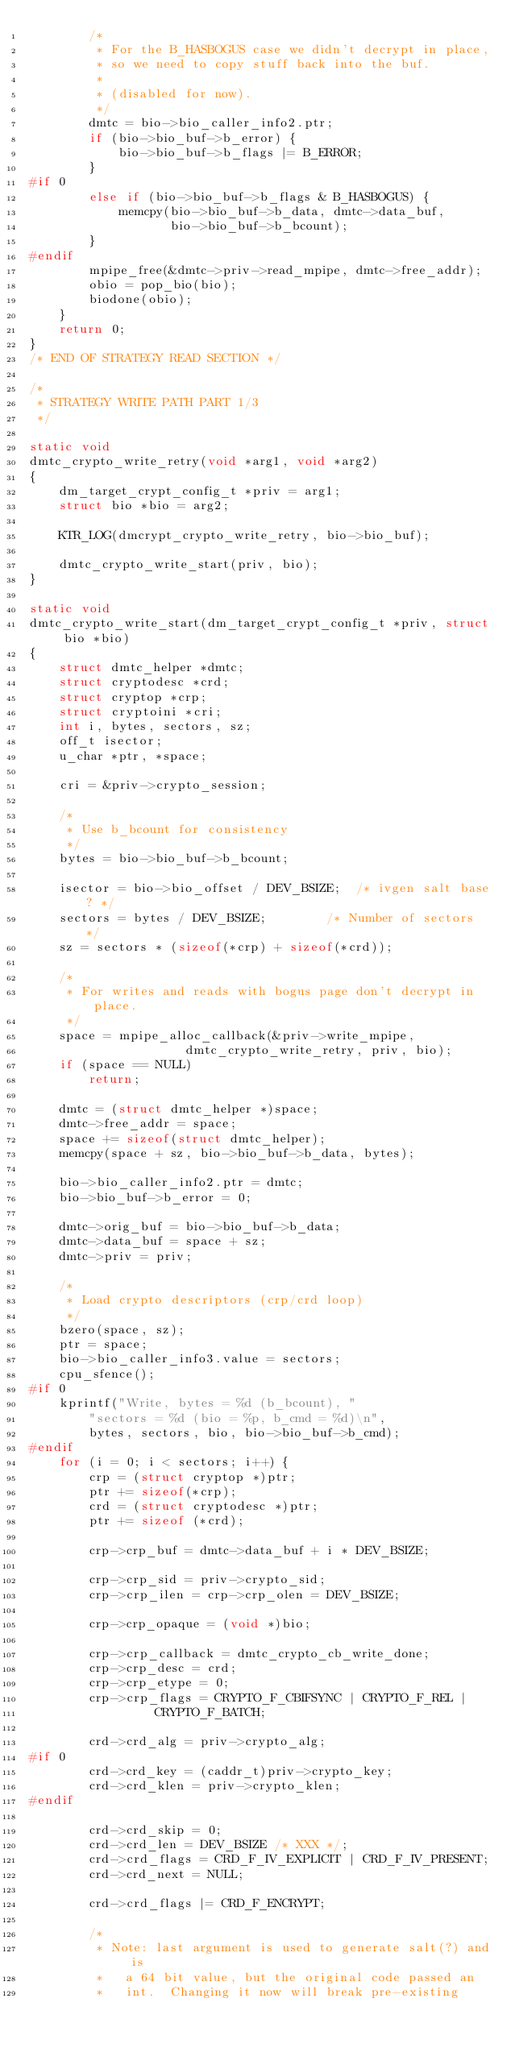<code> <loc_0><loc_0><loc_500><loc_500><_C_>		/*
		 * For the B_HASBOGUS case we didn't decrypt in place,
		 * so we need to copy stuff back into the buf.
		 *
		 * (disabled for now).
		 */
		dmtc = bio->bio_caller_info2.ptr;
		if (bio->bio_buf->b_error) {
			bio->bio_buf->b_flags |= B_ERROR;
		}
#if 0
		else if (bio->bio_buf->b_flags & B_HASBOGUS) {
			memcpy(bio->bio_buf->b_data, dmtc->data_buf,
			       bio->bio_buf->b_bcount);
		}
#endif
		mpipe_free(&dmtc->priv->read_mpipe, dmtc->free_addr);
		obio = pop_bio(bio);
		biodone(obio);
	}
	return 0;
}
/* END OF STRATEGY READ SECTION */

/*
 * STRATEGY WRITE PATH PART 1/3
 */

static void
dmtc_crypto_write_retry(void *arg1, void *arg2)
{
	dm_target_crypt_config_t *priv = arg1;
	struct bio *bio = arg2;

	KTR_LOG(dmcrypt_crypto_write_retry, bio->bio_buf);

	dmtc_crypto_write_start(priv, bio);
}

static void
dmtc_crypto_write_start(dm_target_crypt_config_t *priv, struct bio *bio)
{
	struct dmtc_helper *dmtc;
	struct cryptodesc *crd;
	struct cryptop *crp;
	struct cryptoini *cri;
	int i, bytes, sectors, sz;
	off_t isector;
	u_char *ptr, *space;

	cri = &priv->crypto_session;

	/*
	 * Use b_bcount for consistency
	 */
	bytes = bio->bio_buf->b_bcount;

	isector = bio->bio_offset / DEV_BSIZE;	/* ivgen salt base? */
	sectors = bytes / DEV_BSIZE;		/* Number of sectors */
	sz = sectors * (sizeof(*crp) + sizeof(*crd));

	/*
	 * For writes and reads with bogus page don't decrypt in place.
	 */
	space = mpipe_alloc_callback(&priv->write_mpipe,
				     dmtc_crypto_write_retry, priv, bio);
	if (space == NULL)
		return;

	dmtc = (struct dmtc_helper *)space;
	dmtc->free_addr = space;
	space += sizeof(struct dmtc_helper);
	memcpy(space + sz, bio->bio_buf->b_data, bytes);

	bio->bio_caller_info2.ptr = dmtc;
	bio->bio_buf->b_error = 0;

	dmtc->orig_buf = bio->bio_buf->b_data;
	dmtc->data_buf = space + sz;
	dmtc->priv = priv;

	/*
	 * Load crypto descriptors (crp/crd loop)
	 */
	bzero(space, sz);
	ptr = space;
	bio->bio_caller_info3.value = sectors;
	cpu_sfence();
#if 0
	kprintf("Write, bytes = %d (b_bcount), "
		"sectors = %d (bio = %p, b_cmd = %d)\n",
		bytes, sectors, bio, bio->bio_buf->b_cmd);
#endif
	for (i = 0; i < sectors; i++) {
		crp = (struct cryptop *)ptr;
		ptr += sizeof(*crp);
		crd = (struct cryptodesc *)ptr;
		ptr += sizeof (*crd);

		crp->crp_buf = dmtc->data_buf + i * DEV_BSIZE;

		crp->crp_sid = priv->crypto_sid;
		crp->crp_ilen = crp->crp_olen = DEV_BSIZE;

		crp->crp_opaque = (void *)bio;

		crp->crp_callback = dmtc_crypto_cb_write_done;
		crp->crp_desc = crd;
		crp->crp_etype = 0;
		crp->crp_flags = CRYPTO_F_CBIFSYNC | CRYPTO_F_REL |
				 CRYPTO_F_BATCH;

		crd->crd_alg = priv->crypto_alg;
#if 0
		crd->crd_key = (caddr_t)priv->crypto_key;
		crd->crd_klen = priv->crypto_klen;
#endif

		crd->crd_skip = 0;
		crd->crd_len = DEV_BSIZE /* XXX */;
		crd->crd_flags = CRD_F_IV_EXPLICIT | CRD_F_IV_PRESENT;
		crd->crd_next = NULL;

		crd->crd_flags |= CRD_F_ENCRYPT;

		/*
		 * Note: last argument is used to generate salt(?) and is
		 *	 a 64 bit value, but the original code passed an
		 *	 int.  Changing it now will break pre-existing</code> 